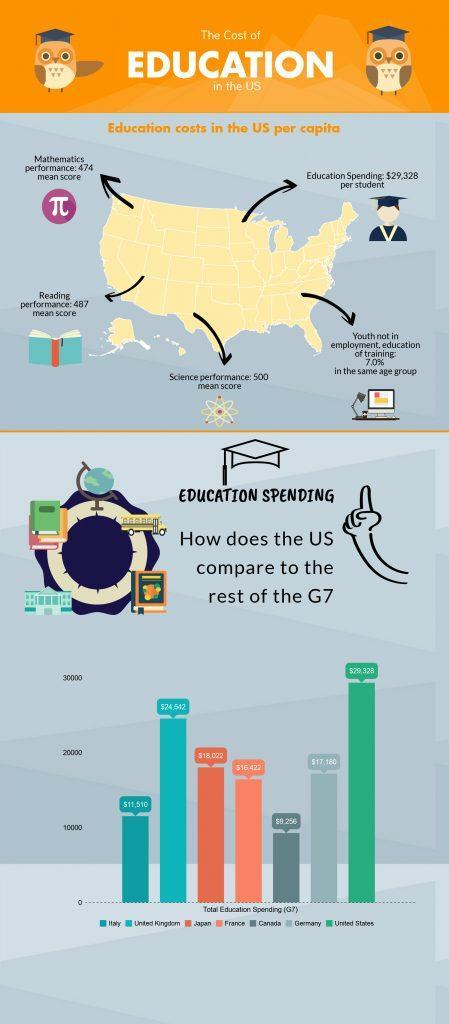Calculate the difference between the highest value spent on education spending and the lowest value on education ?
Answer the question with a short phrase. $ 21,072 What is difference if the total education spending of US and UK ? $ 4,816 Which of the following countries spend the highest for education France, Japan, or Canada? Japan Calculate the Total Education Spending by all the G7 countries? $ 125,230 Which of the following countries spend the lowest for education UK, Germany, or Italy? Italy 